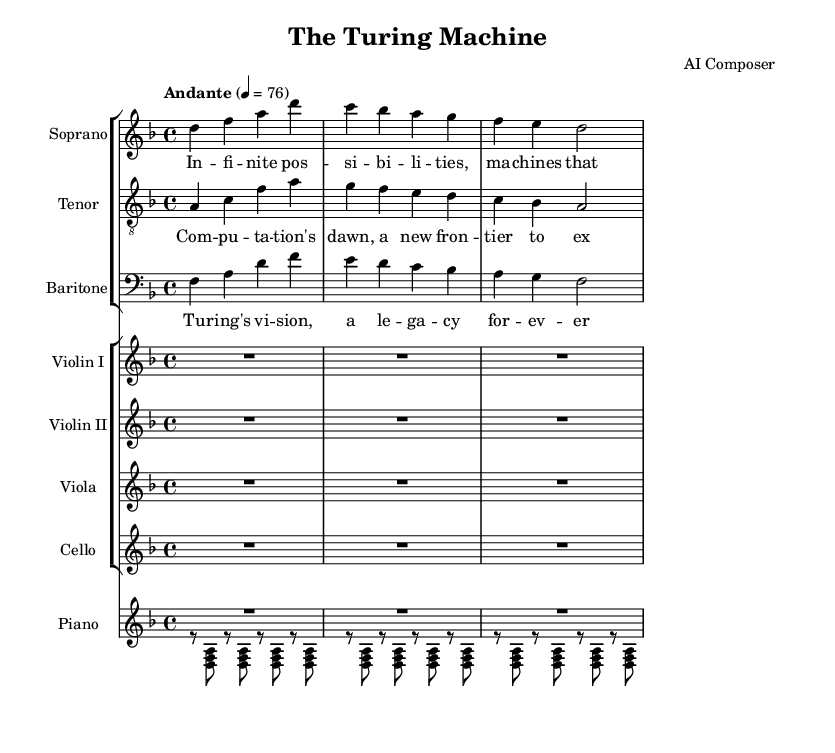What is the key signature of this music? The key signature is D minor, as indicated by the two flats (B flat and E flat) present in the music.
Answer: D minor What is the time signature of this music? The time signature shown at the beginning is 4/4, meaning there are four beats in each measure and the quarter note gets one beat.
Answer: 4/4 What is the tempo marking for the piece? The tempo marking is Andante, indicated by the direction in the score, which describes a moderately slow tempo.
Answer: Andante How many voices are written for the singers? There are three voices: soprano, tenor, and baritone, as indicated by the separate staves for each voice in the score.
Answer: Three What instrument plays the longest rest in this piece? The strings (violin I, violin II, viola, and cello) have whole rests indicated by R1*3, meaning they rest for three beats in each measure.
Answer: Strings What is the central theme expressed in the soprano lyrics? The soprano lyrics reflect the idea of infinite possibilities and thinking machines, highlighting themes of innovation and technology.
Answer: Infinite possibilities Which historical figure is referenced in the baritone lyrics? The baritone lyrics mention Turing, referring to Alan Turing, a pivotal figure in computer science and technology.
Answer: Turing 